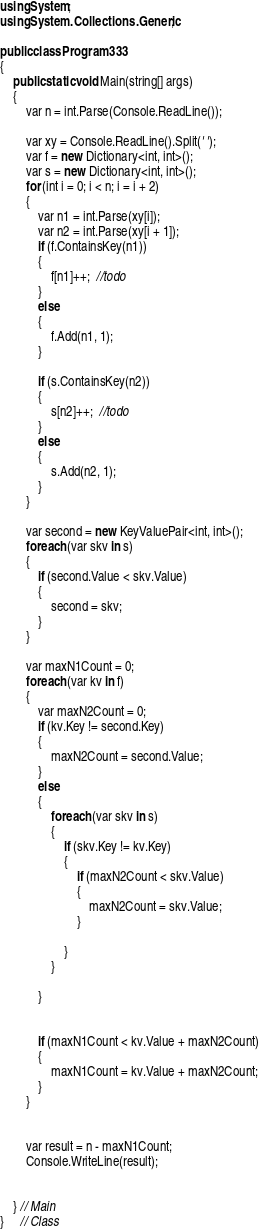Convert code to text. <code><loc_0><loc_0><loc_500><loc_500><_C#_>using System;
using System.Collections.Generic;

public class Program333
{
    public static void Main(string[] args)
    {
        var n = int.Parse(Console.ReadLine());

        var xy = Console.ReadLine().Split(' ');
        var f = new Dictionary<int, int>();
        var s = new Dictionary<int, int>();
        for (int i = 0; i < n; i = i + 2)
        {
            var n1 = int.Parse(xy[i]);
            var n2 = int.Parse(xy[i + 1]);
            if (f.ContainsKey(n1))
            {
                f[n1]++;  //todo
            }
            else
            {
                f.Add(n1, 1);
            }

            if (s.ContainsKey(n2))
            {
                s[n2]++;  //todo
            }
            else
            {
                s.Add(n2, 1);
            }
        }

        var second = new KeyValuePair<int, int>();
        foreach (var skv in s)
        {
            if (second.Value < skv.Value)
            {
                second = skv;
            }
        }

        var maxN1Count = 0;
        foreach (var kv in f)
        {
            var maxN2Count = 0;
            if (kv.Key != second.Key)
            {
                maxN2Count = second.Value;
            }
            else
            {
                foreach (var skv in s)
                {
                    if (skv.Key != kv.Key)
                    {
                        if (maxN2Count < skv.Value)
                        {
                            maxN2Count = skv.Value;
                        }

                    }
                }

            }


            if (maxN1Count < kv.Value + maxN2Count)
            {
                maxN1Count = kv.Value + maxN2Count;
            }
        }


        var result = n - maxN1Count;
        Console.WriteLine(result);


    } // Main
}     // Class



</code> 